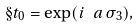<formula> <loc_0><loc_0><loc_500><loc_500>\S t _ { 0 } = \exp ( i \ a \, \sigma _ { 3 } ) ,</formula> 